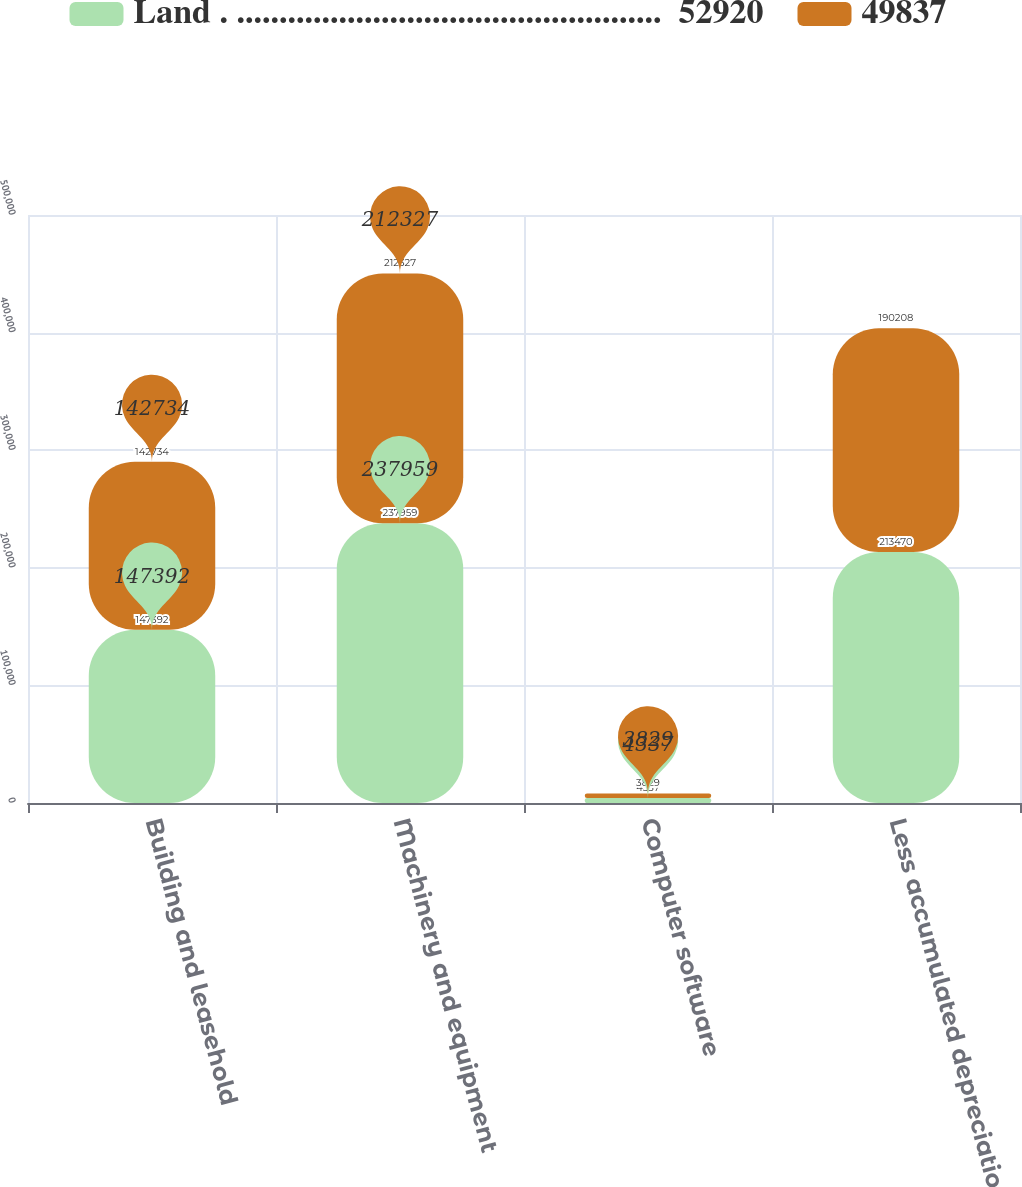Convert chart to OTSL. <chart><loc_0><loc_0><loc_500><loc_500><stacked_bar_chart><ecel><fcel>Building and leasehold<fcel>Machinery and equipment<fcel>Computer software<fcel>Less accumulated depreciation<nl><fcel>Land . ..................................................  52920<fcel>147392<fcel>237959<fcel>4337<fcel>213470<nl><fcel>49837<fcel>142734<fcel>212327<fcel>3829<fcel>190208<nl></chart> 